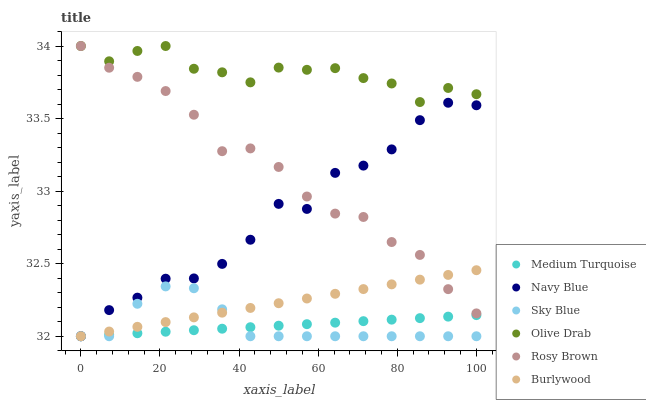Does Medium Turquoise have the minimum area under the curve?
Answer yes or no. Yes. Does Olive Drab have the maximum area under the curve?
Answer yes or no. Yes. Does Navy Blue have the minimum area under the curve?
Answer yes or no. No. Does Navy Blue have the maximum area under the curve?
Answer yes or no. No. Is Burlywood the smoothest?
Answer yes or no. Yes. Is Navy Blue the roughest?
Answer yes or no. Yes. Is Rosy Brown the smoothest?
Answer yes or no. No. Is Rosy Brown the roughest?
Answer yes or no. No. Does Burlywood have the lowest value?
Answer yes or no. Yes. Does Rosy Brown have the lowest value?
Answer yes or no. No. Does Olive Drab have the highest value?
Answer yes or no. Yes. Does Navy Blue have the highest value?
Answer yes or no. No. Is Sky Blue less than Olive Drab?
Answer yes or no. Yes. Is Olive Drab greater than Navy Blue?
Answer yes or no. Yes. Does Sky Blue intersect Burlywood?
Answer yes or no. Yes. Is Sky Blue less than Burlywood?
Answer yes or no. No. Is Sky Blue greater than Burlywood?
Answer yes or no. No. Does Sky Blue intersect Olive Drab?
Answer yes or no. No. 